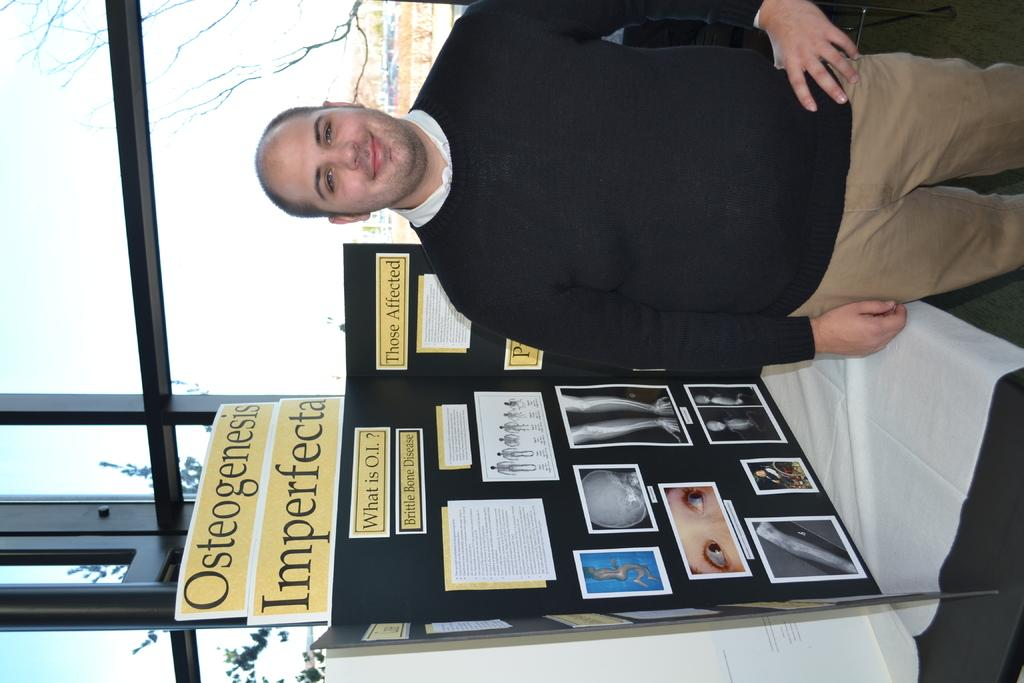<image>
Relay a brief, clear account of the picture shown. A man in a black sweater stands next to a poster that says Osteogenesis Imperfecta. 